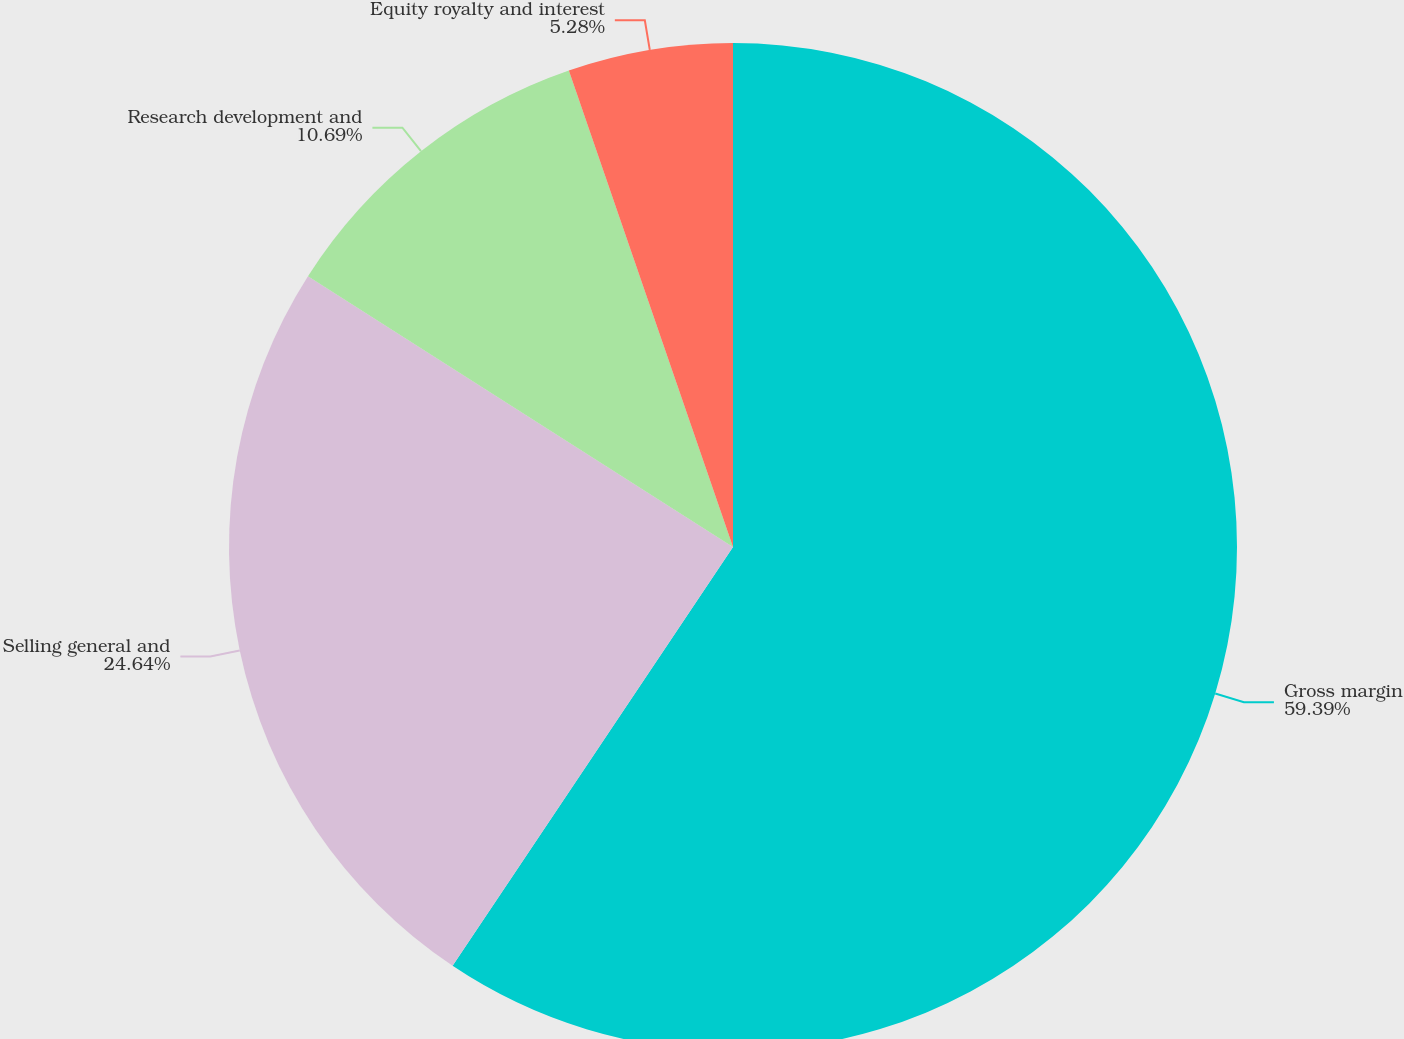Convert chart. <chart><loc_0><loc_0><loc_500><loc_500><pie_chart><fcel>Gross margin<fcel>Selling general and<fcel>Research development and<fcel>Equity royalty and interest<nl><fcel>59.39%<fcel>24.64%<fcel>10.69%<fcel>5.28%<nl></chart> 